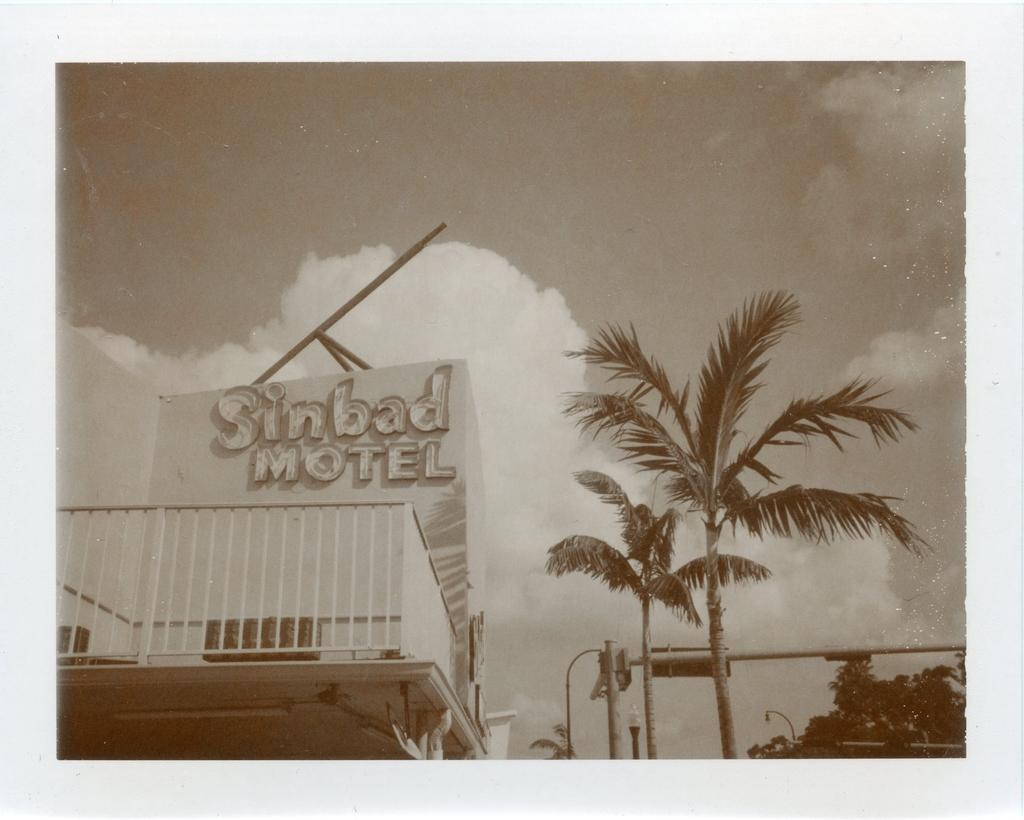What is the color scheme of the image? The image is black and white. What type of structure can be seen in the image? There is a building in the image. What other natural elements are present in the image? There are trees in the image. What man-made objects can be seen in the image? There are poles and lights in the image. What is visible in the sky at the top of the image? There are clouds in the sky at the top of the image. How many zebras can be seen crossing the road in the image? There are no zebras or roads present in the image. What type of discovery was made at the location depicted in the image? There is no indication of a discovery in the image; it simply shows a building, trees, poles, lights, and clouds. 